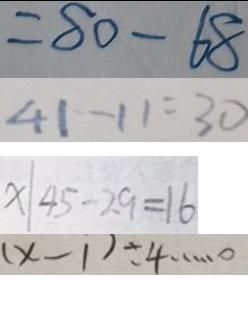<formula> <loc_0><loc_0><loc_500><loc_500>= 8 0 - 6 8 
 4 1 - 1 1 = 3 0 
 x \vert 4 5 - 2 9 = 1 6 
 ( x - 1 ) \div 4 \cdots 0</formula> 